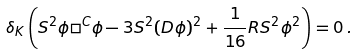<formula> <loc_0><loc_0><loc_500><loc_500>\delta _ { K } \left ( S ^ { 2 } \phi \Box ^ { C } \phi - 3 S ^ { 2 } ( D \phi ) ^ { 2 } + \frac { 1 } { 1 6 } R S ^ { 2 } \phi ^ { 2 } \right ) = 0 \, .</formula> 